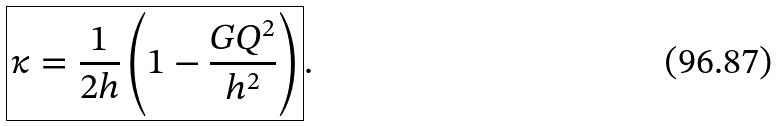Convert formula to latex. <formula><loc_0><loc_0><loc_500><loc_500>\boxed { \kappa = \frac { 1 } { 2 h } \left ( 1 - \frac { G Q ^ { 2 } } { h ^ { 2 } } \right ) } .</formula> 